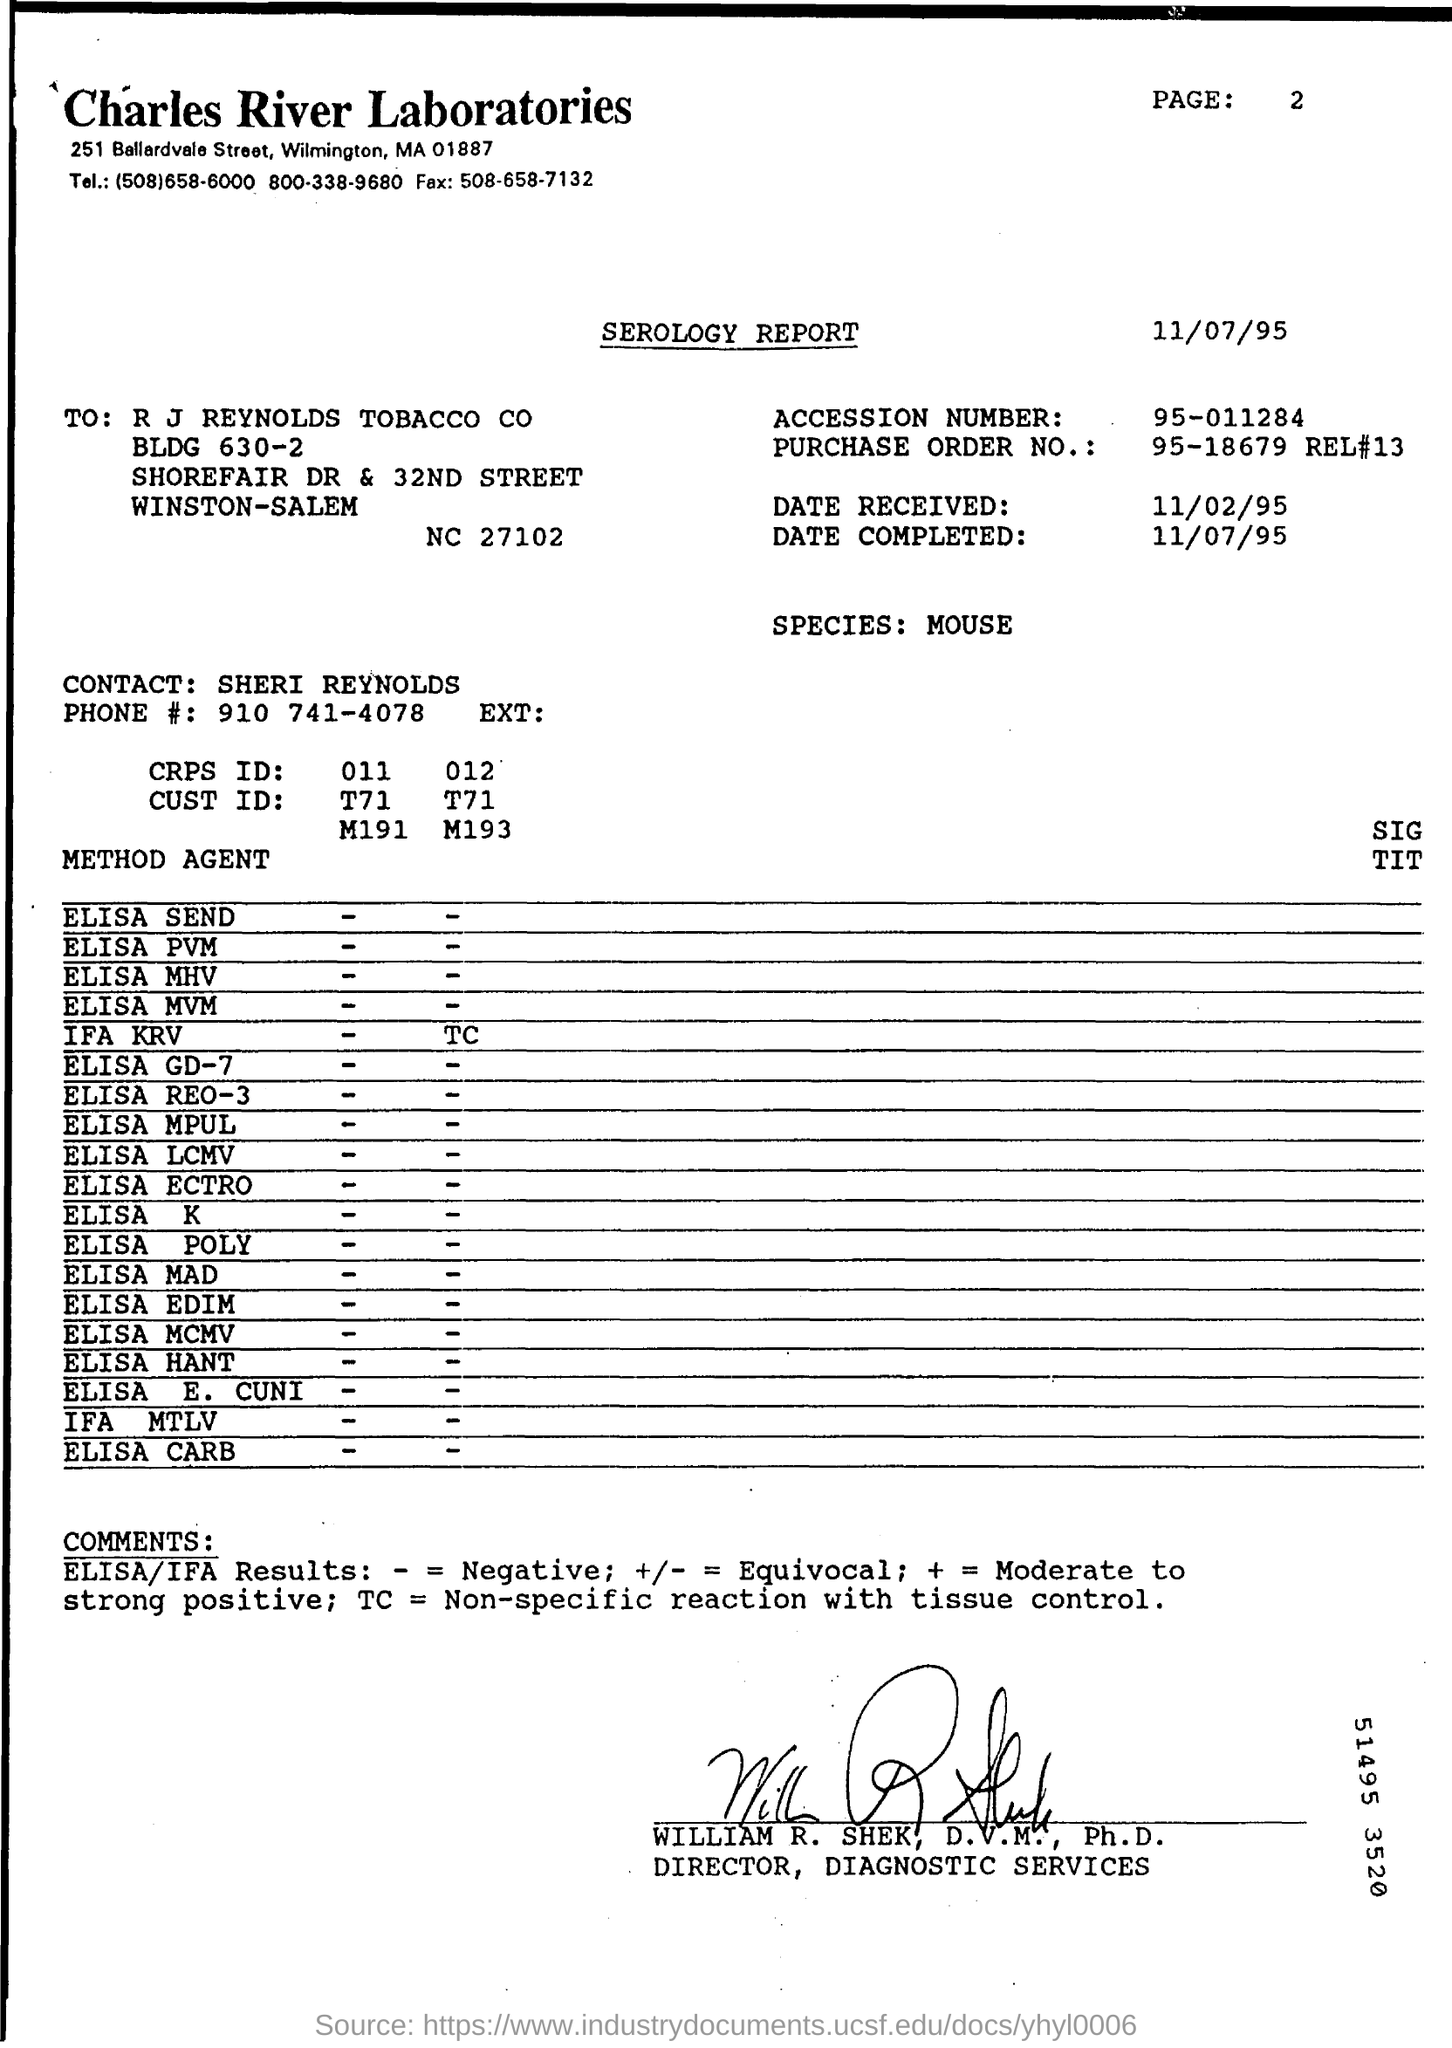Highlight a few significant elements in this photo. The accession number mentioned in the report is 95-011284.. The report has been signed by William R. Shek. The test uses a specific species of mouse. This is a serology report. This laboratory report was conducted by Charles River Laboratories. 